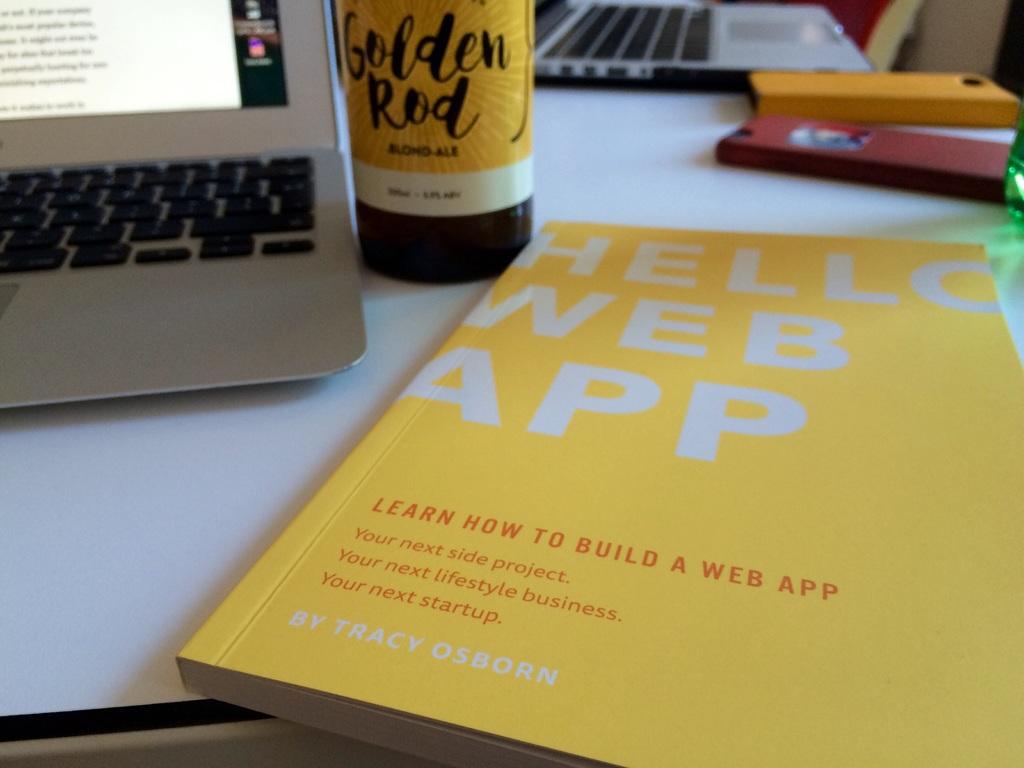What can you learn to do by reading the yellow book?
Your response must be concise. Build a web app. 